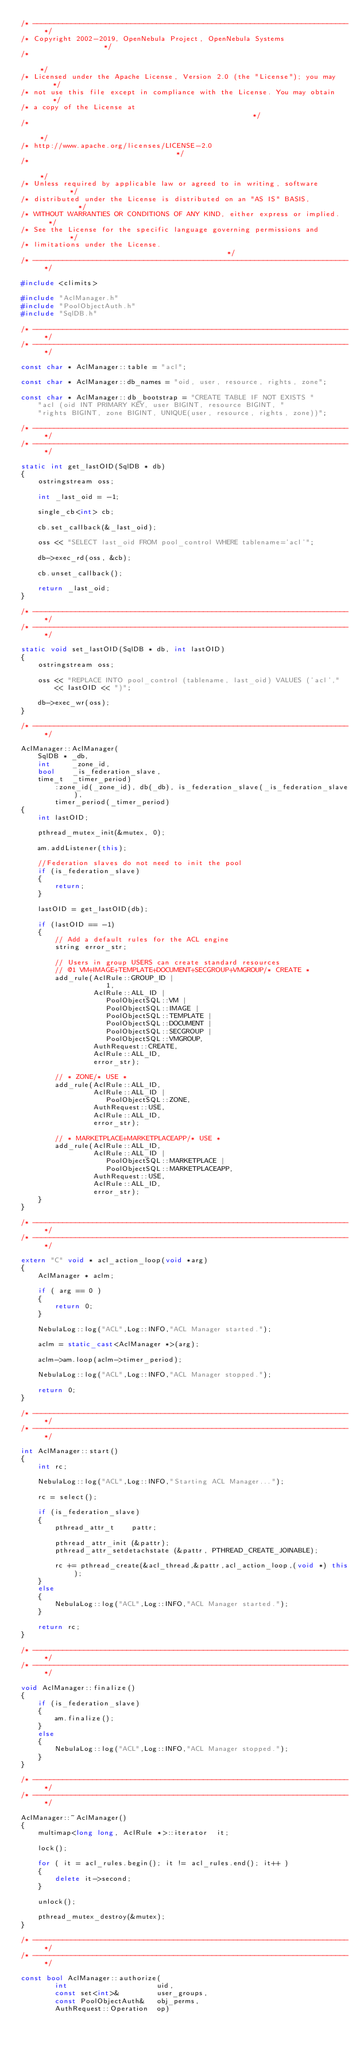Convert code to text. <code><loc_0><loc_0><loc_500><loc_500><_C++_>/* -------------------------------------------------------------------------- */
/* Copyright 2002-2019, OpenNebula Project, OpenNebula Systems                */
/*                                                                            */
/* Licensed under the Apache License, Version 2.0 (the "License"); you may    */
/* not use this file except in compliance with the License. You may obtain    */
/* a copy of the License at                                                   */
/*                                                                            */
/* http://www.apache.org/licenses/LICENSE-2.0                                 */
/*                                                                            */
/* Unless required by applicable law or agreed to in writing, software        */
/* distributed under the License is distributed on an "AS IS" BASIS,          */
/* WITHOUT WARRANTIES OR CONDITIONS OF ANY KIND, either express or implied.   */
/* See the License for the specific language governing permissions and        */
/* limitations under the License.                                             */
/* -------------------------------------------------------------------------- */

#include <climits>

#include "AclManager.h"
#include "PoolObjectAuth.h"
#include "SqlDB.h"

/* -------------------------------------------------------------------------- */
/* -------------------------------------------------------------------------- */

const char * AclManager::table = "acl";

const char * AclManager::db_names = "oid, user, resource, rights, zone";

const char * AclManager::db_bootstrap = "CREATE TABLE IF NOT EXISTS "
    "acl (oid INT PRIMARY KEY, user BIGINT, resource BIGINT, "
    "rights BIGINT, zone BIGINT, UNIQUE(user, resource, rights, zone))";

/* -------------------------------------------------------------------------- */
/* -------------------------------------------------------------------------- */

static int get_lastOID(SqlDB * db)
{
    ostringstream oss;

    int _last_oid = -1;

    single_cb<int> cb;

    cb.set_callback(&_last_oid);

    oss << "SELECT last_oid FROM pool_control WHERE tablename='acl'";

    db->exec_rd(oss, &cb);

    cb.unset_callback();

    return _last_oid;
}

/* -------------------------------------------------------------------------- */
/* -------------------------------------------------------------------------- */

static void set_lastOID(SqlDB * db, int lastOID)
{
    ostringstream oss;

    oss << "REPLACE INTO pool_control (tablename, last_oid) VALUES ('acl',"
        << lastOID << ")";

    db->exec_wr(oss);
}

/* -------------------------------------------------------------------------- */

AclManager::AclManager(
    SqlDB * _db,
    int     _zone_id,
    bool    _is_federation_slave,
    time_t  _timer_period)
        :zone_id(_zone_id), db(_db), is_federation_slave(_is_federation_slave),
        timer_period(_timer_period)
{
    int lastOID;

    pthread_mutex_init(&mutex, 0);

    am.addListener(this);

    //Federation slaves do not need to init the pool
    if (is_federation_slave)
    {
        return;
    }

    lastOID = get_lastOID(db);

    if (lastOID == -1)
    {
        // Add a default rules for the ACL engine
        string error_str;

        // Users in group USERS can create standard resources
        // @1 VM+IMAGE+TEMPLATE+DOCUMENT+SECGROUP+VMGROUP/* CREATE *
        add_rule(AclRule::GROUP_ID |
                    1,
                 AclRule::ALL_ID |
                    PoolObjectSQL::VM |
                    PoolObjectSQL::IMAGE |
                    PoolObjectSQL::TEMPLATE |
                    PoolObjectSQL::DOCUMENT |
                    PoolObjectSQL::SECGROUP |
                    PoolObjectSQL::VMGROUP,
                 AuthRequest::CREATE,
                 AclRule::ALL_ID,
                 error_str);

        // * ZONE/* USE *
        add_rule(AclRule::ALL_ID,
                 AclRule::ALL_ID |
                    PoolObjectSQL::ZONE,
                 AuthRequest::USE,
                 AclRule::ALL_ID,
                 error_str);

        // * MARKETPLACE+MARKETPLACEAPP/* USE *
        add_rule(AclRule::ALL_ID,
                 AclRule::ALL_ID |
                    PoolObjectSQL::MARKETPLACE |
                    PoolObjectSQL::MARKETPLACEAPP,
                 AuthRequest::USE,
                 AclRule::ALL_ID,
                 error_str);
    }
}

/* -------------------------------------------------------------------------- */
/* -------------------------------------------------------------------------- */

extern "C" void * acl_action_loop(void *arg)
{
    AclManager * aclm;

    if ( arg == 0 )
    {
        return 0;
    }

    NebulaLog::log("ACL",Log::INFO,"ACL Manager started.");

    aclm = static_cast<AclManager *>(arg);

    aclm->am.loop(aclm->timer_period);

    NebulaLog::log("ACL",Log::INFO,"ACL Manager stopped.");

    return 0;
}

/* -------------------------------------------------------------------------- */
/* -------------------------------------------------------------------------- */

int AclManager::start()
{
    int rc;

    NebulaLog::log("ACL",Log::INFO,"Starting ACL Manager...");

    rc = select();

    if (is_federation_slave)
    {
        pthread_attr_t    pattr;

        pthread_attr_init (&pattr);
        pthread_attr_setdetachstate (&pattr, PTHREAD_CREATE_JOINABLE);

        rc += pthread_create(&acl_thread,&pattr,acl_action_loop,(void *) this);
    }
    else
    {
        NebulaLog::log("ACL",Log::INFO,"ACL Manager started.");
    }

    return rc;
}

/* -------------------------------------------------------------------------- */
/* -------------------------------------------------------------------------- */

void AclManager::finalize()
{
    if (is_federation_slave)
    {
        am.finalize();
    }
    else
    {
        NebulaLog::log("ACL",Log::INFO,"ACL Manager stopped.");
    }
}

/* -------------------------------------------------------------------------- */
/* -------------------------------------------------------------------------- */

AclManager::~AclManager()
{
    multimap<long long, AclRule *>::iterator  it;

    lock();

    for ( it = acl_rules.begin(); it != acl_rules.end(); it++ )
    {
        delete it->second;
    }

    unlock();

    pthread_mutex_destroy(&mutex);
}

/* -------------------------------------------------------------------------- */
/* -------------------------------------------------------------------------- */

const bool AclManager::authorize(
        int                     uid,
        const set<int>&         user_groups,
        const PoolObjectAuth&   obj_perms,
        AuthRequest::Operation  op)</code> 